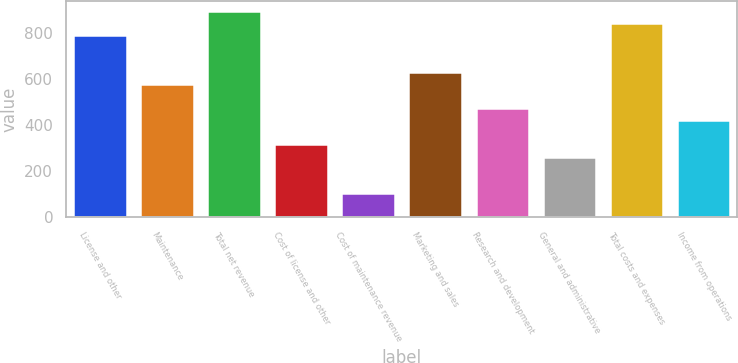Convert chart to OTSL. <chart><loc_0><loc_0><loc_500><loc_500><bar_chart><fcel>License and other<fcel>Maintenance<fcel>Total net revenue<fcel>Cost of license and other<fcel>Cost of maintenance revenue<fcel>Marketing and sales<fcel>Research and development<fcel>General and administrative<fcel>Total costs and expenses<fcel>Income from operations<nl><fcel>788.63<fcel>578.43<fcel>893.73<fcel>315.68<fcel>105.48<fcel>630.98<fcel>473.33<fcel>263.13<fcel>841.18<fcel>420.78<nl></chart> 